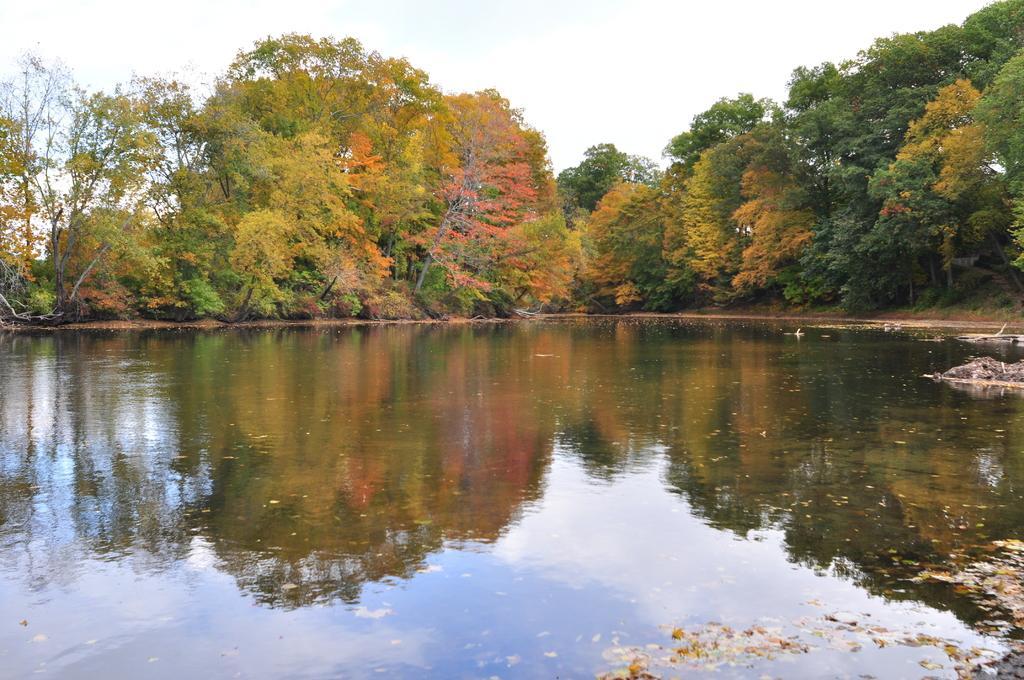How would you summarize this image in a sentence or two? We can see water. In the background we can see trees and sky. On this water we can see reflection of trees and sky with clouds. 